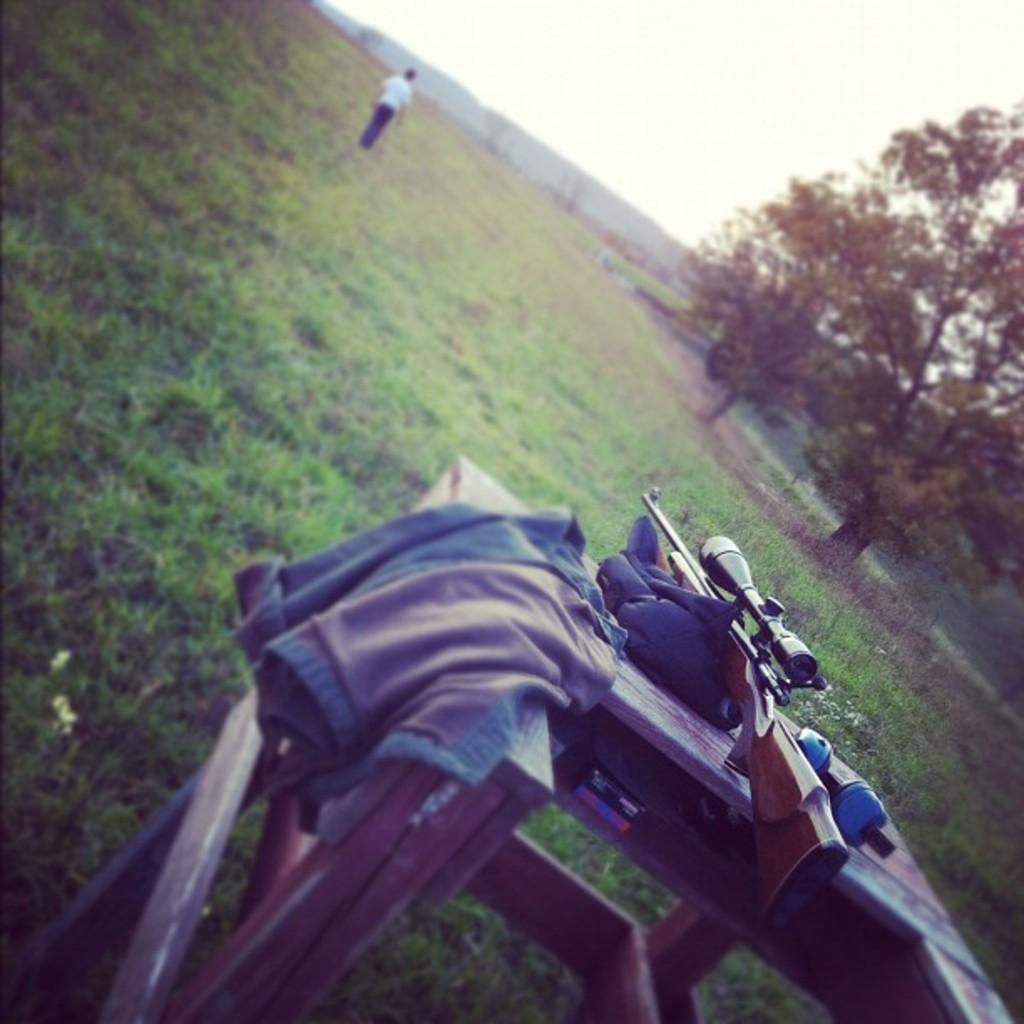What object is located in the foreground of the image? There is a gun in the foreground of the image. What is placed on the table in the foreground? Headphones are placed on a table in the foreground. What can be seen in the background of the image? There is a person standing and trees are visible in the background of the image. What part of the natural environment is visible in the image? The sky is visible in the background of the image. What is the effect of the actor's performance on the audience in the image? There is no actor or audience present in the image, so it is not possible to determine the effect of the actor's performance. 